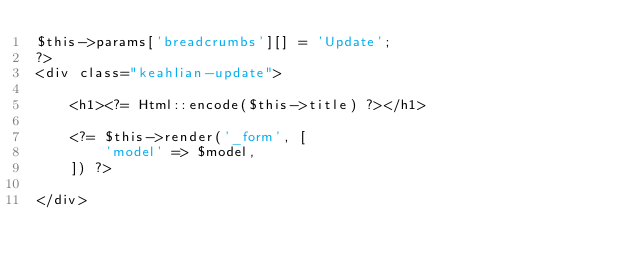Convert code to text. <code><loc_0><loc_0><loc_500><loc_500><_PHP_>$this->params['breadcrumbs'][] = 'Update';
?>
<div class="keahlian-update">

    <h1><?= Html::encode($this->title) ?></h1>

    <?= $this->render('_form', [
        'model' => $model,
    ]) ?>

</div>
</code> 